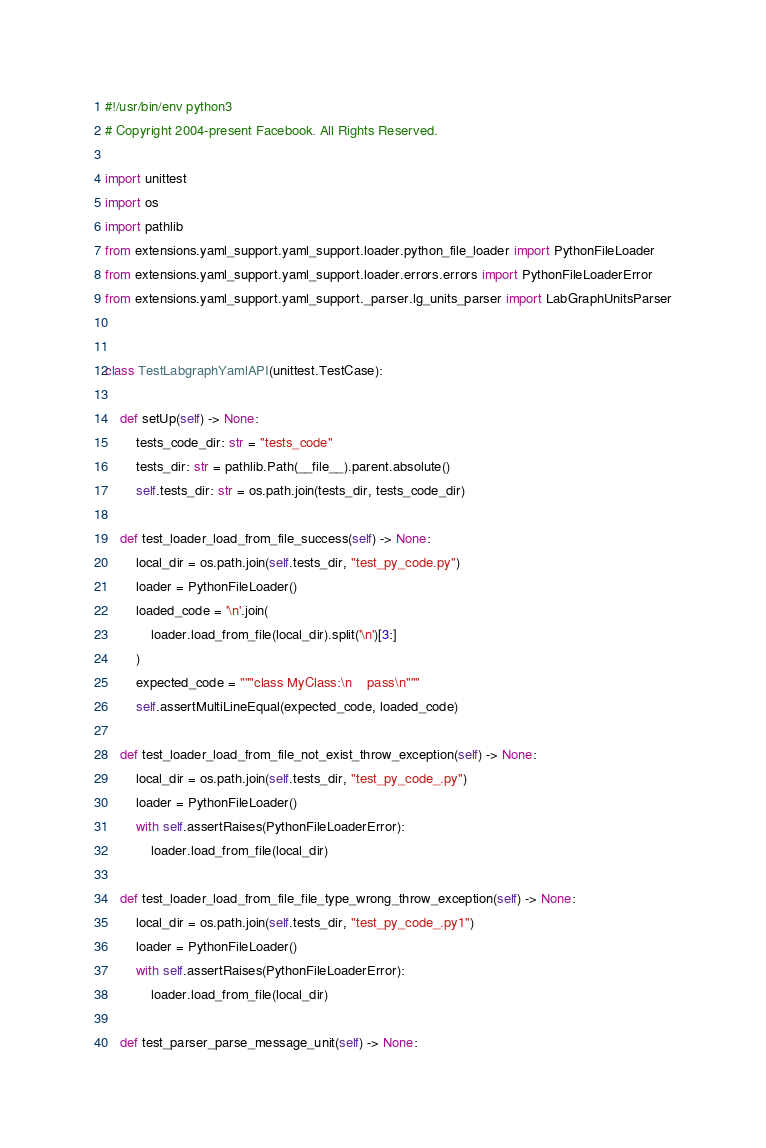Convert code to text. <code><loc_0><loc_0><loc_500><loc_500><_Python_>#!/usr/bin/env python3
# Copyright 2004-present Facebook. All Rights Reserved.

import unittest
import os
import pathlib
from extensions.yaml_support.yaml_support.loader.python_file_loader import PythonFileLoader
from extensions.yaml_support.yaml_support.loader.errors.errors import PythonFileLoaderError
from extensions.yaml_support.yaml_support._parser.lg_units_parser import LabGraphUnitsParser


class TestLabgraphYamlAPI(unittest.TestCase):

    def setUp(self) -> None:
        tests_code_dir: str = "tests_code"
        tests_dir: str = pathlib.Path(__file__).parent.absolute()
        self.tests_dir: str = os.path.join(tests_dir, tests_code_dir)

    def test_loader_load_from_file_success(self) -> None:
        local_dir = os.path.join(self.tests_dir, "test_py_code.py")
        loader = PythonFileLoader()
        loaded_code = '\n'.join(
            loader.load_from_file(local_dir).split('\n')[3:]
        )
        expected_code = """class MyClass:\n    pass\n"""
        self.assertMultiLineEqual(expected_code, loaded_code)

    def test_loader_load_from_file_not_exist_throw_exception(self) -> None:
        local_dir = os.path.join(self.tests_dir, "test_py_code_.py")
        loader = PythonFileLoader()
        with self.assertRaises(PythonFileLoaderError):
            loader.load_from_file(local_dir)

    def test_loader_load_from_file_file_type_wrong_throw_exception(self) -> None:
        local_dir = os.path.join(self.tests_dir, "test_py_code_.py1")
        loader = PythonFileLoader()
        with self.assertRaises(PythonFileLoaderError):
            loader.load_from_file(local_dir)

    def test_parser_parse_message_unit(self) -> None:</code> 